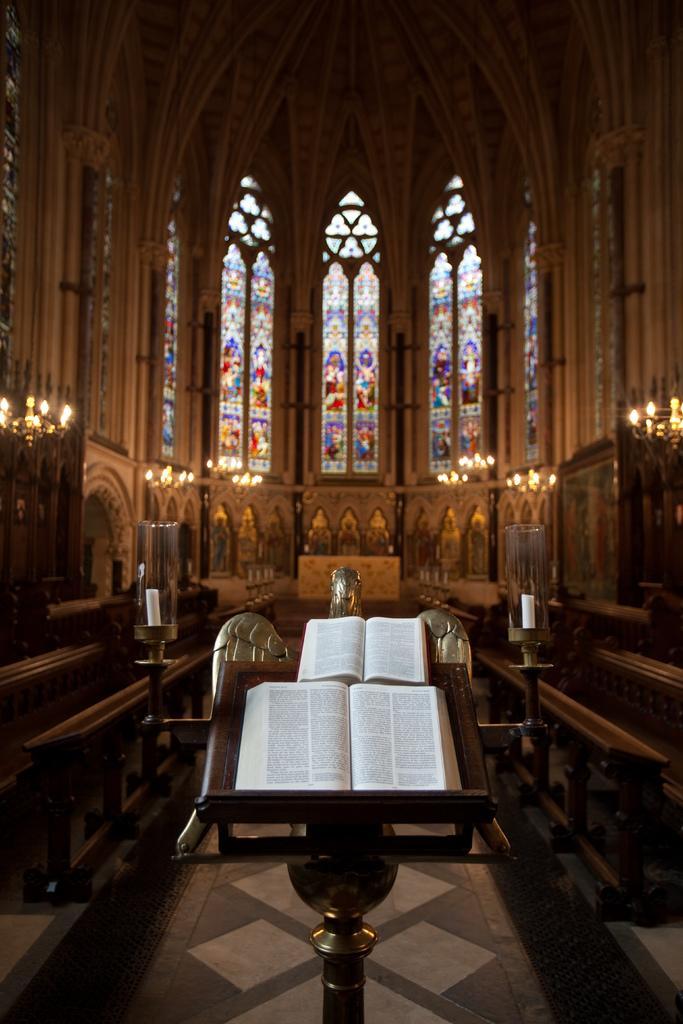Could you give a brief overview of what you see in this image? In this image I can see inside view of the building and I can see a colorful wall , in the wall I can see colorful lights , in the foreground I can see a stand , on the stand I can see books 